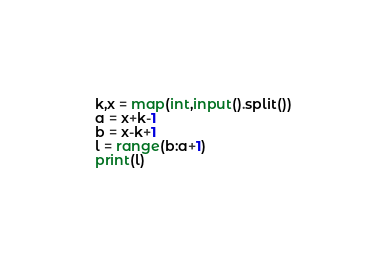Convert code to text. <code><loc_0><loc_0><loc_500><loc_500><_Python_>k,x = map(int,input().split())
a = x+k-1
b = x-k+1
l = range(b:a+1)
print(l)
</code> 